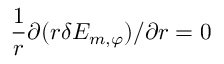<formula> <loc_0><loc_0><loc_500><loc_500>\frac { 1 } { r } { \partial } ( r \delta E _ { m , \varphi } ) / { \partial r } = 0</formula> 